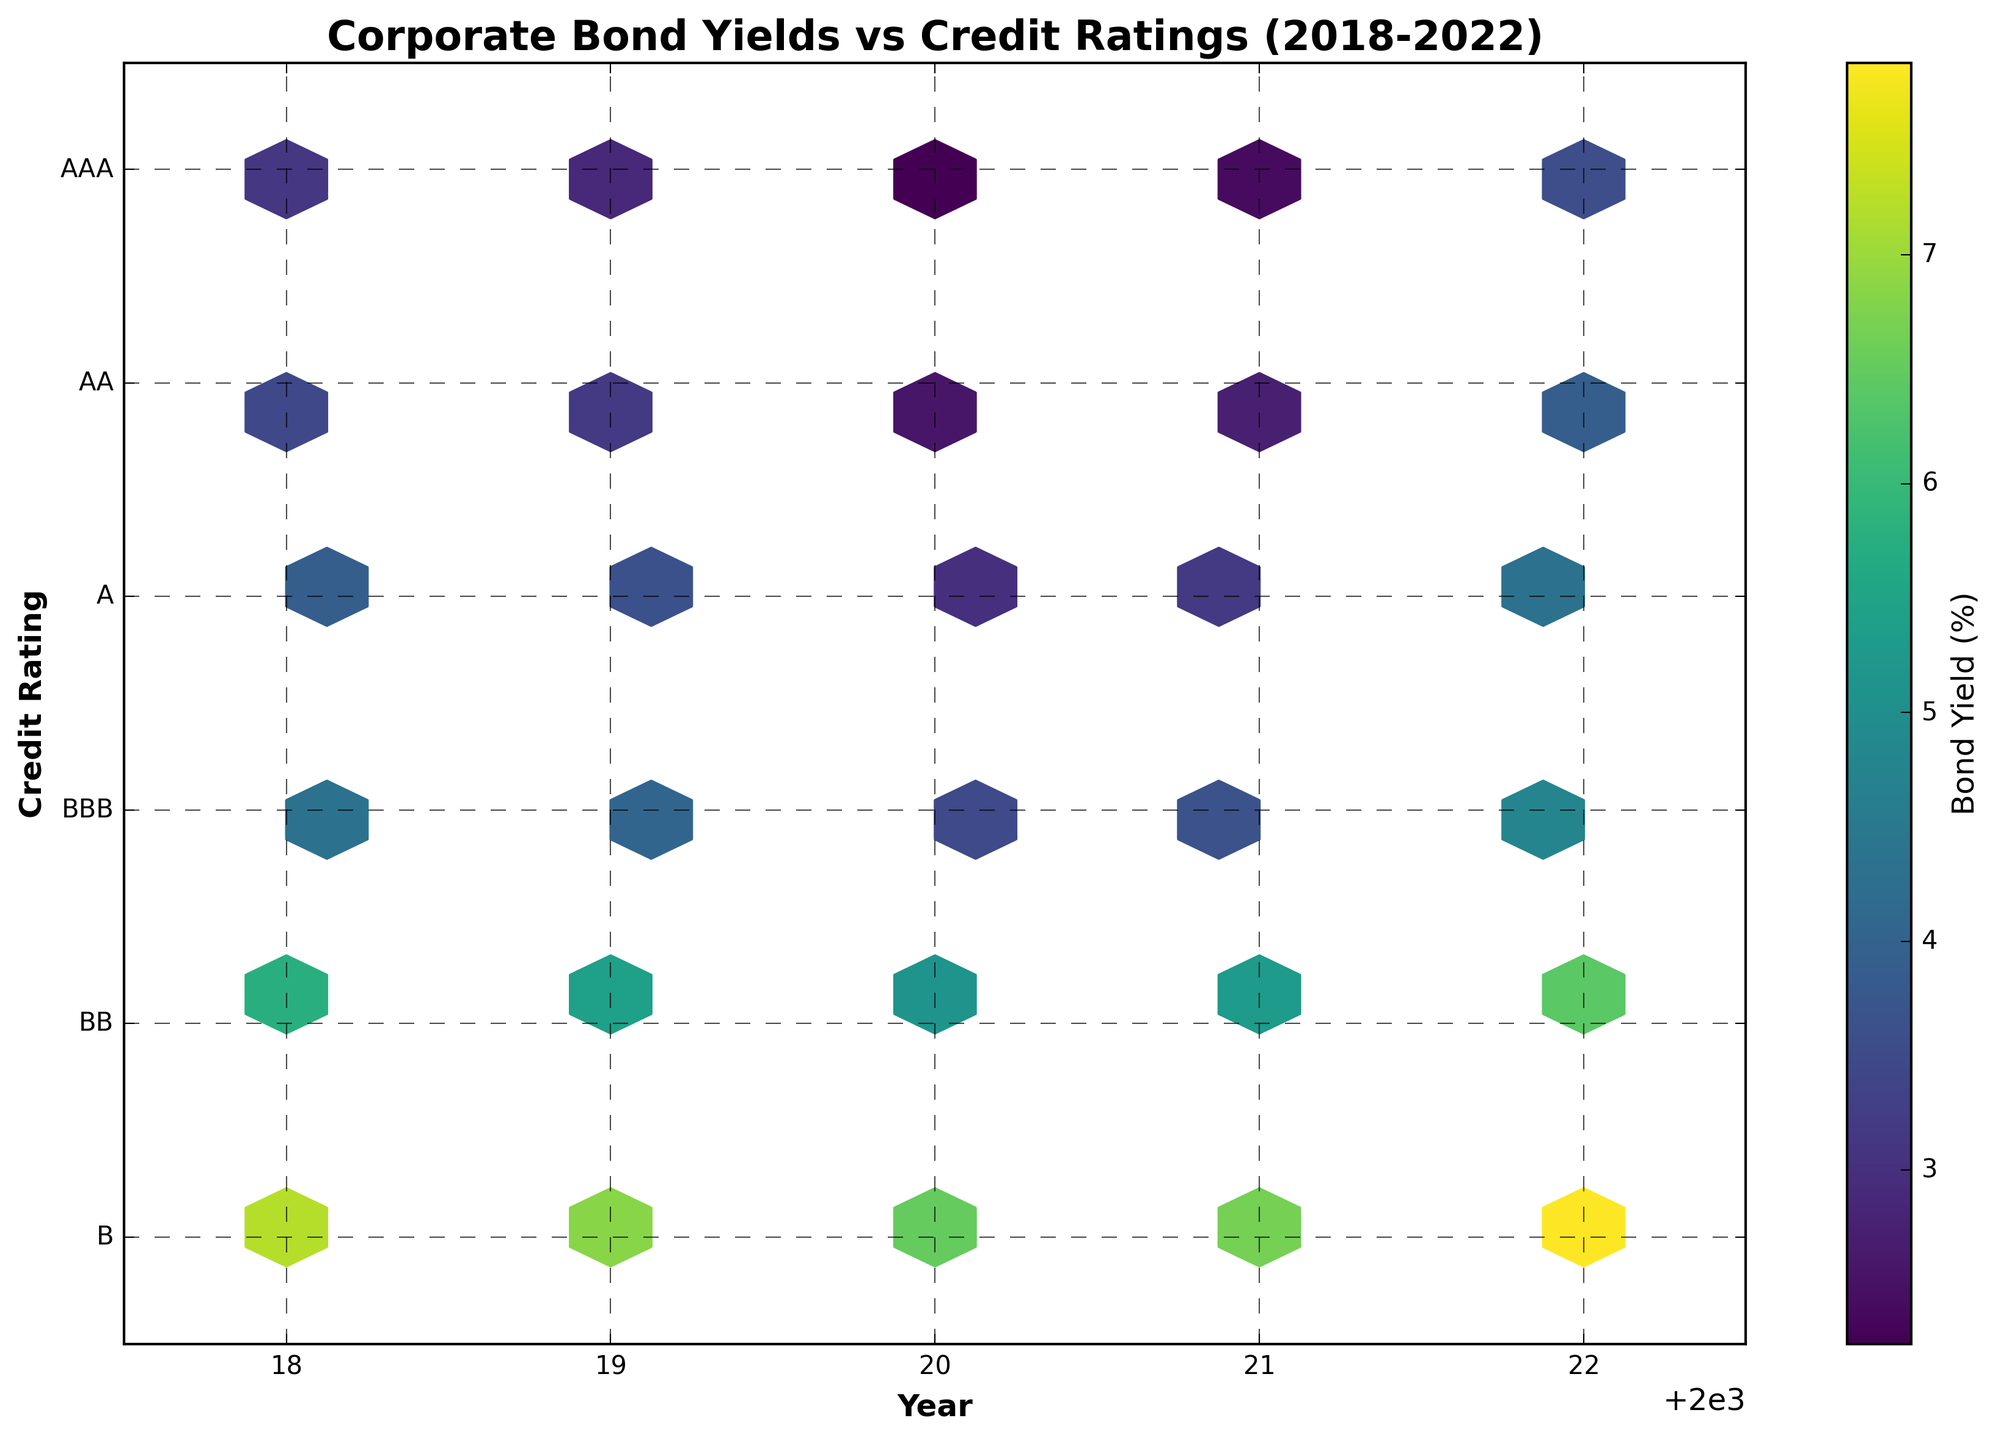What is the title of the plot? The title is typically located at the top of the plot. It provides an overview of what the plot is about.
Answer: Corporate Bond Yields vs Credit Ratings (2018-2022) What are the x-axis and y-axis labels? The labels explain what each axis represents. The x-axis label is at the bottom (horizontal), and the y-axis label is on the left (vertical).
Answer: The x-axis label is "Year" and the y-axis label is "Credit Rating" Which years are covered in the data? Look along the x-axis to determine the range of years displayed on the plot.
Answer: 2018 to 2022 Which credit rating experienced the highest bond yields in 2020? Follow the year 2020 on the x-axis and identify the highest bond yield value on the color scale for each rating on the y-axis.
Answer: B rating How does the bond yield for AAA credit rating in 2022 compare to 2020? Find the bond yield for AAA rating in both 2022 and 2020 using the colors or the color bar legend, then compare the values.
Answer: It increased from 2.24% in 2020 to 3.56% in 2022 In which year did the bond yield for AA credit rating show the highest value? Check the bond yield values for AA rating across different years using the color gradient. Identify the year with the darkest color indicating the highest value.
Answer: 2022 Which credit rating had the most consistent bond yield over the years? Compare the hexbins for each rating across years and look for the rating with the least variation in bond yield values.
Answer: AAA rating (visually similar bond yields each year) What is the approximate bond yield range for BB credit rating in 2019? Find the 2019 hexbin locations for BB rating, then determine the bond yields using the color bar to identify the range.
Answer: Between approximately 5.41% By how much did the bond yield for BBB rating increase from 2020 to 2022? Find the value for BBB in 2020 and 2022, and calculate the difference between these yields.
Answer: Increased by 1.29% (4.78% - 3.49%) What trends can be observed in the bond yields for credit ratings A and BBB from 2018 to 2022? For each of these credit ratings, follow the hexbin pattern through the years and note if the bond yields are increasing, decreasing, or fluctuating.
Answer: Both yields generally increased over time 